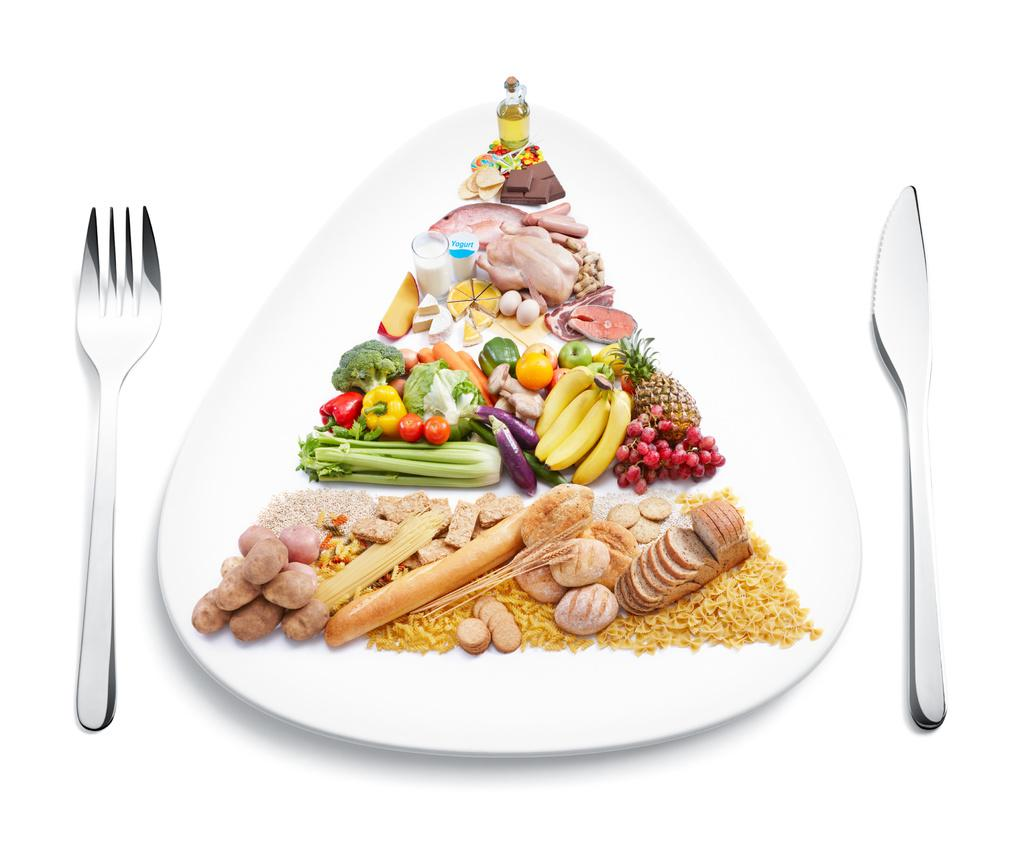What is the main subject in the foreground of the image? There is food on a platter in the foreground of the image. What utensils are present near the platter? There is a knife on one side of the platter and a fork on the other side. What type of punishment is the queen administering in the image? There is no queen or any indication of punishment in the image; it features food on a platter with a knife and fork. 